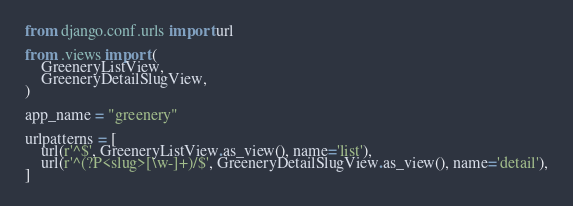<code> <loc_0><loc_0><loc_500><loc_500><_Python_>from django.conf.urls import url

from .views import (
    GreeneryListView,
    GreeneryDetailSlugView,
)

app_name = "greenery"

urlpatterns = [
    url(r'^$', GreeneryListView.as_view(), name='list'),
    url(r'^(?P<slug>[\w-]+)/$', GreeneryDetailSlugView.as_view(), name='detail'),
]

</code> 